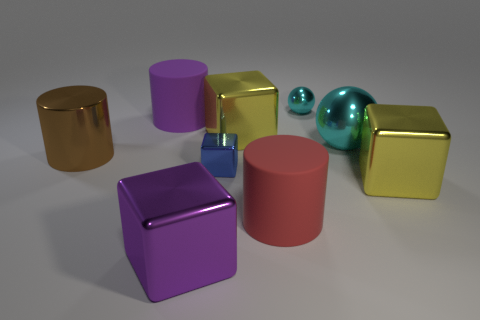Are there more tiny cyan balls than gray objects?
Provide a short and direct response. Yes. There is a metal cube that is both in front of the small blue shiny thing and behind the purple cube; what size is it?
Provide a succinct answer. Large. There is a big purple rubber thing; what shape is it?
Your answer should be very brief. Cylinder. What number of large red rubber things are the same shape as the big purple matte object?
Make the answer very short. 1. Are there fewer big purple things behind the blue metal block than small blue cubes that are behind the small sphere?
Provide a short and direct response. No. There is a cylinder that is right of the purple block; how many metallic balls are to the left of it?
Provide a short and direct response. 0. Are there any big green metal cubes?
Give a very brief answer. No. Is there a big brown cylinder made of the same material as the tiny cyan thing?
Your response must be concise. Yes. Is the number of large shiny blocks that are in front of the large sphere greater than the number of purple metallic things that are behind the brown cylinder?
Give a very brief answer. Yes. Does the purple block have the same size as the purple cylinder?
Provide a succinct answer. Yes. 